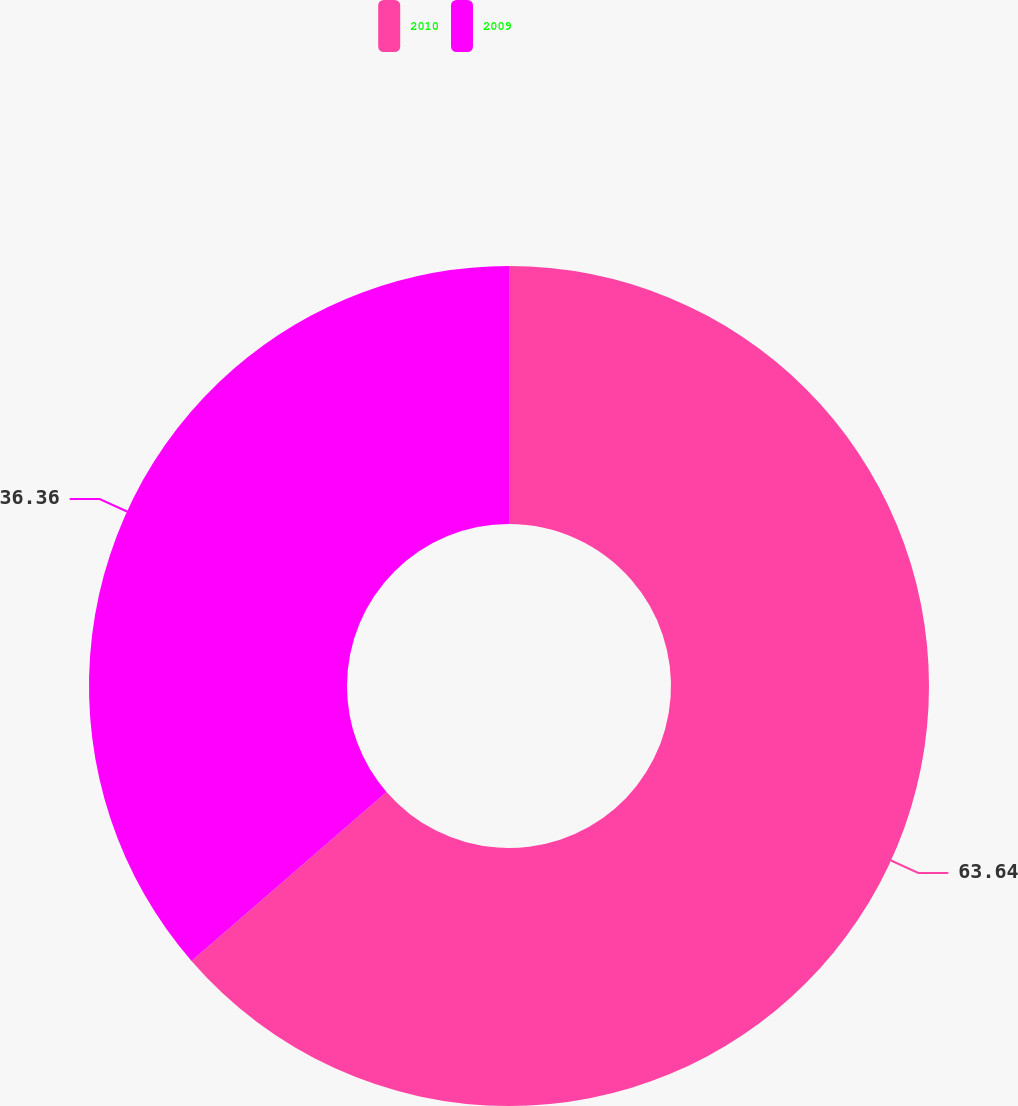<chart> <loc_0><loc_0><loc_500><loc_500><pie_chart><fcel>2010<fcel>2009<nl><fcel>63.64%<fcel>36.36%<nl></chart> 